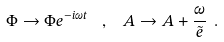Convert formula to latex. <formula><loc_0><loc_0><loc_500><loc_500>\Phi \rightarrow \Phi e ^ { - i \omega t } \ \ , \ \ A \rightarrow A + \frac { \omega } { \tilde { e } } \ .</formula> 